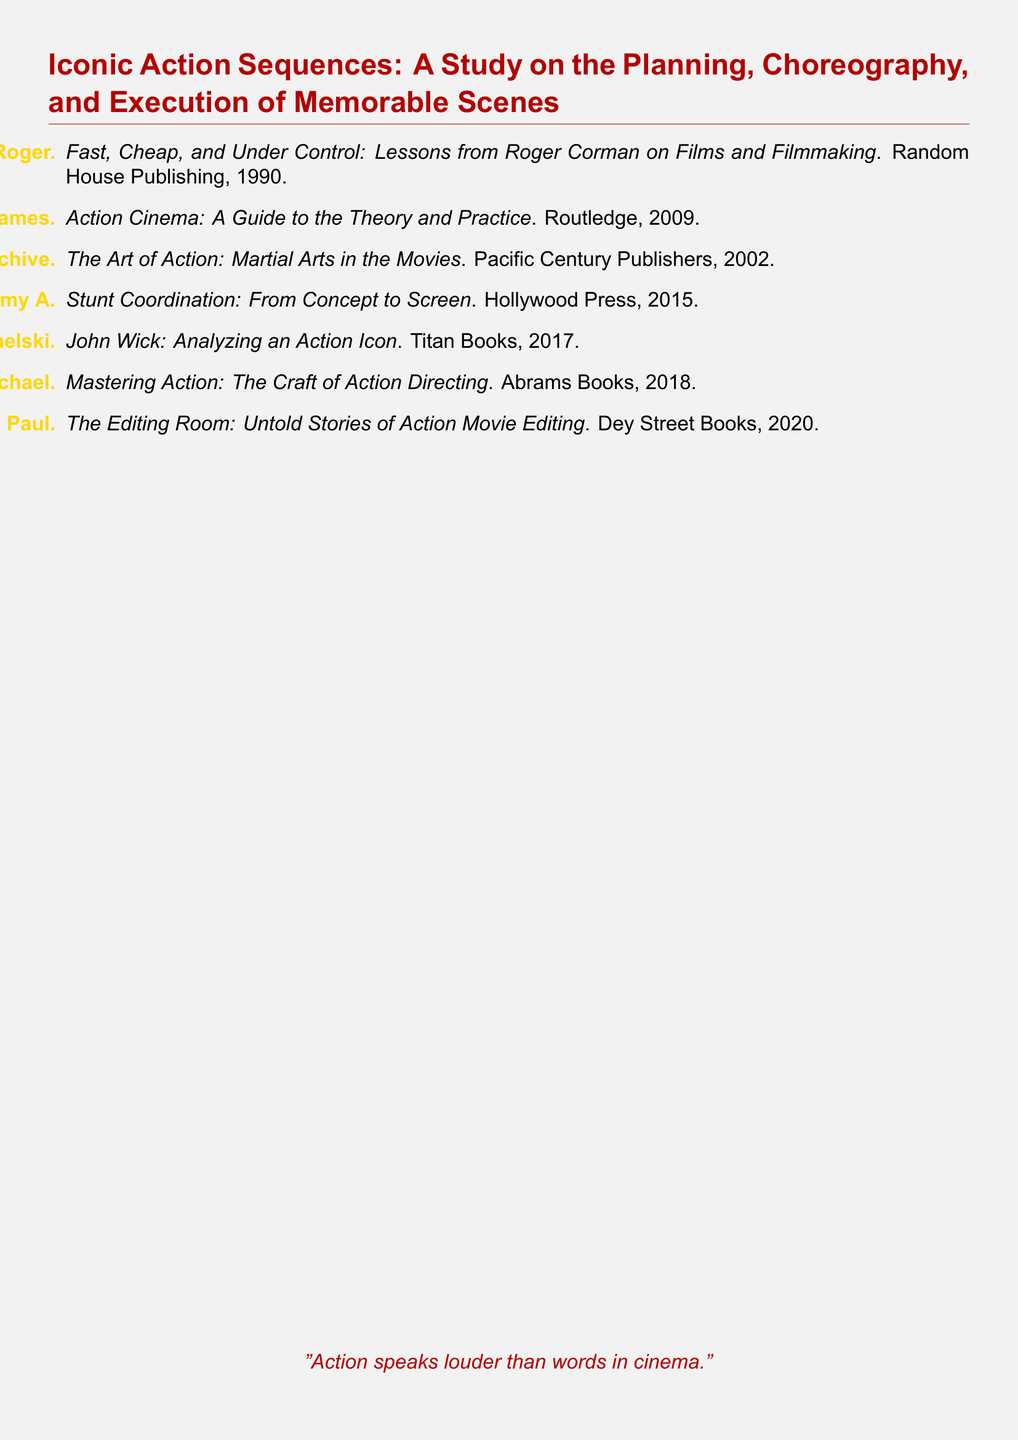What is the title of the document? The title is specified at the beginning of the document as "Iconic Action Sequences: A Study on the Planning, Choreography, and Execution of Memorable Scenes."
Answer: Iconic Action Sequences: A Study on the Planning, Choreography, and Execution of Memorable Scenes Who is the author of the book "Fast, Cheap, and Under Control"? The author is mentioned in the document as Roger Corman.
Answer: Roger Corman What year was "Stunt Coordination: From Concept to Screen" published? The publication year for this book is indicated in the document as 2015.
Answer: 2015 Which publisher released "Action Cinema: A Guide to the Theory and Practice"? The publisher is identified in the document as Routledge.
Answer: Routledge What color is used for section titles in the document? The section titles are formatted with the color actionred as defined in the document.
Answer: actionred Which two authors collaborated on the book "John Wick: Analyzing an Action Icon"? The document lists David Leitch and Chad Stahelski as the authors.
Answer: David Leitch and Chad Stahelski What is the main subject of the bibliography? The main subject includes the planning, choreography, and execution of memorable action sequences in films.
Answer: Planning, choreography, and execution of memorable action sequences How many books are listed in the bibliography? The total number of entries in the document indicates there are seven books listed.
Answer: Seven What genre does the book "The Art of Action: Martial Arts in the Movies" belong to? It belongs to the genre of films specifically focused on martial arts.
Answer: Martial arts 